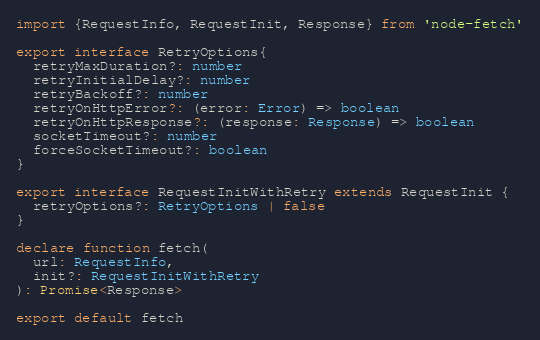Convert code to text. <code><loc_0><loc_0><loc_500><loc_500><_TypeScript_>import {RequestInfo, RequestInit, Response} from 'node-fetch'

export interface RetryOptions{
  retryMaxDuration?: number
  retryInitialDelay?: number
  retryBackoff?: number
  retryOnHttpError?: (error: Error) => boolean
  retryOnHttpResponse?: (response: Response) => boolean
  socketTimeout?: number
  forceSocketTimeout?: boolean
}

export interface RequestInitWithRetry extends RequestInit {
  retryOptions?: RetryOptions | false
}

declare function fetch(
  url: RequestInfo,
  init?: RequestInitWithRetry
): Promise<Response>

export default fetch
</code> 